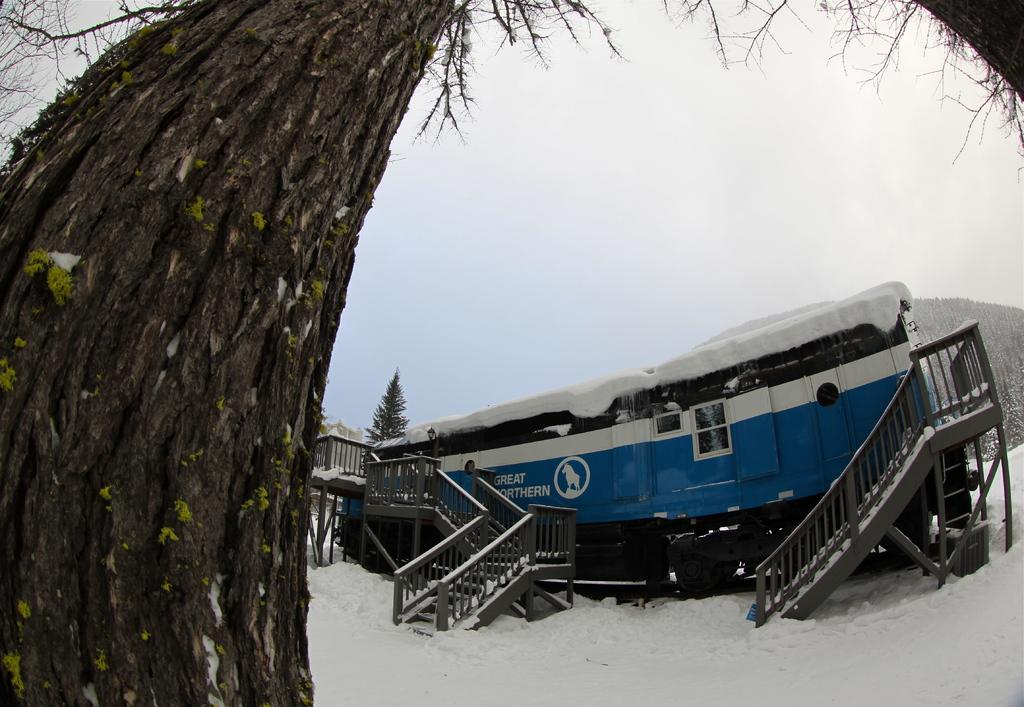What is the main subject in the center of the image? There is a vehicle in the center of the image. What type of natural elements can be seen in the image? Trees are visible in the image. Are there any architectural features present in the image? Yes, there are stairs in the image. What is the ground condition at the bottom of the image? There is snow at the bottom of the image. What can be seen in the background of the image? The sky is visible in the background of the image. What type of company is hosting a feast in the image? There is no company or feast present in the image; it features a vehicle, trees, stairs, snow, and the sky. What is the size of the nose of the person in the image? There is no person or nose present in the image. 